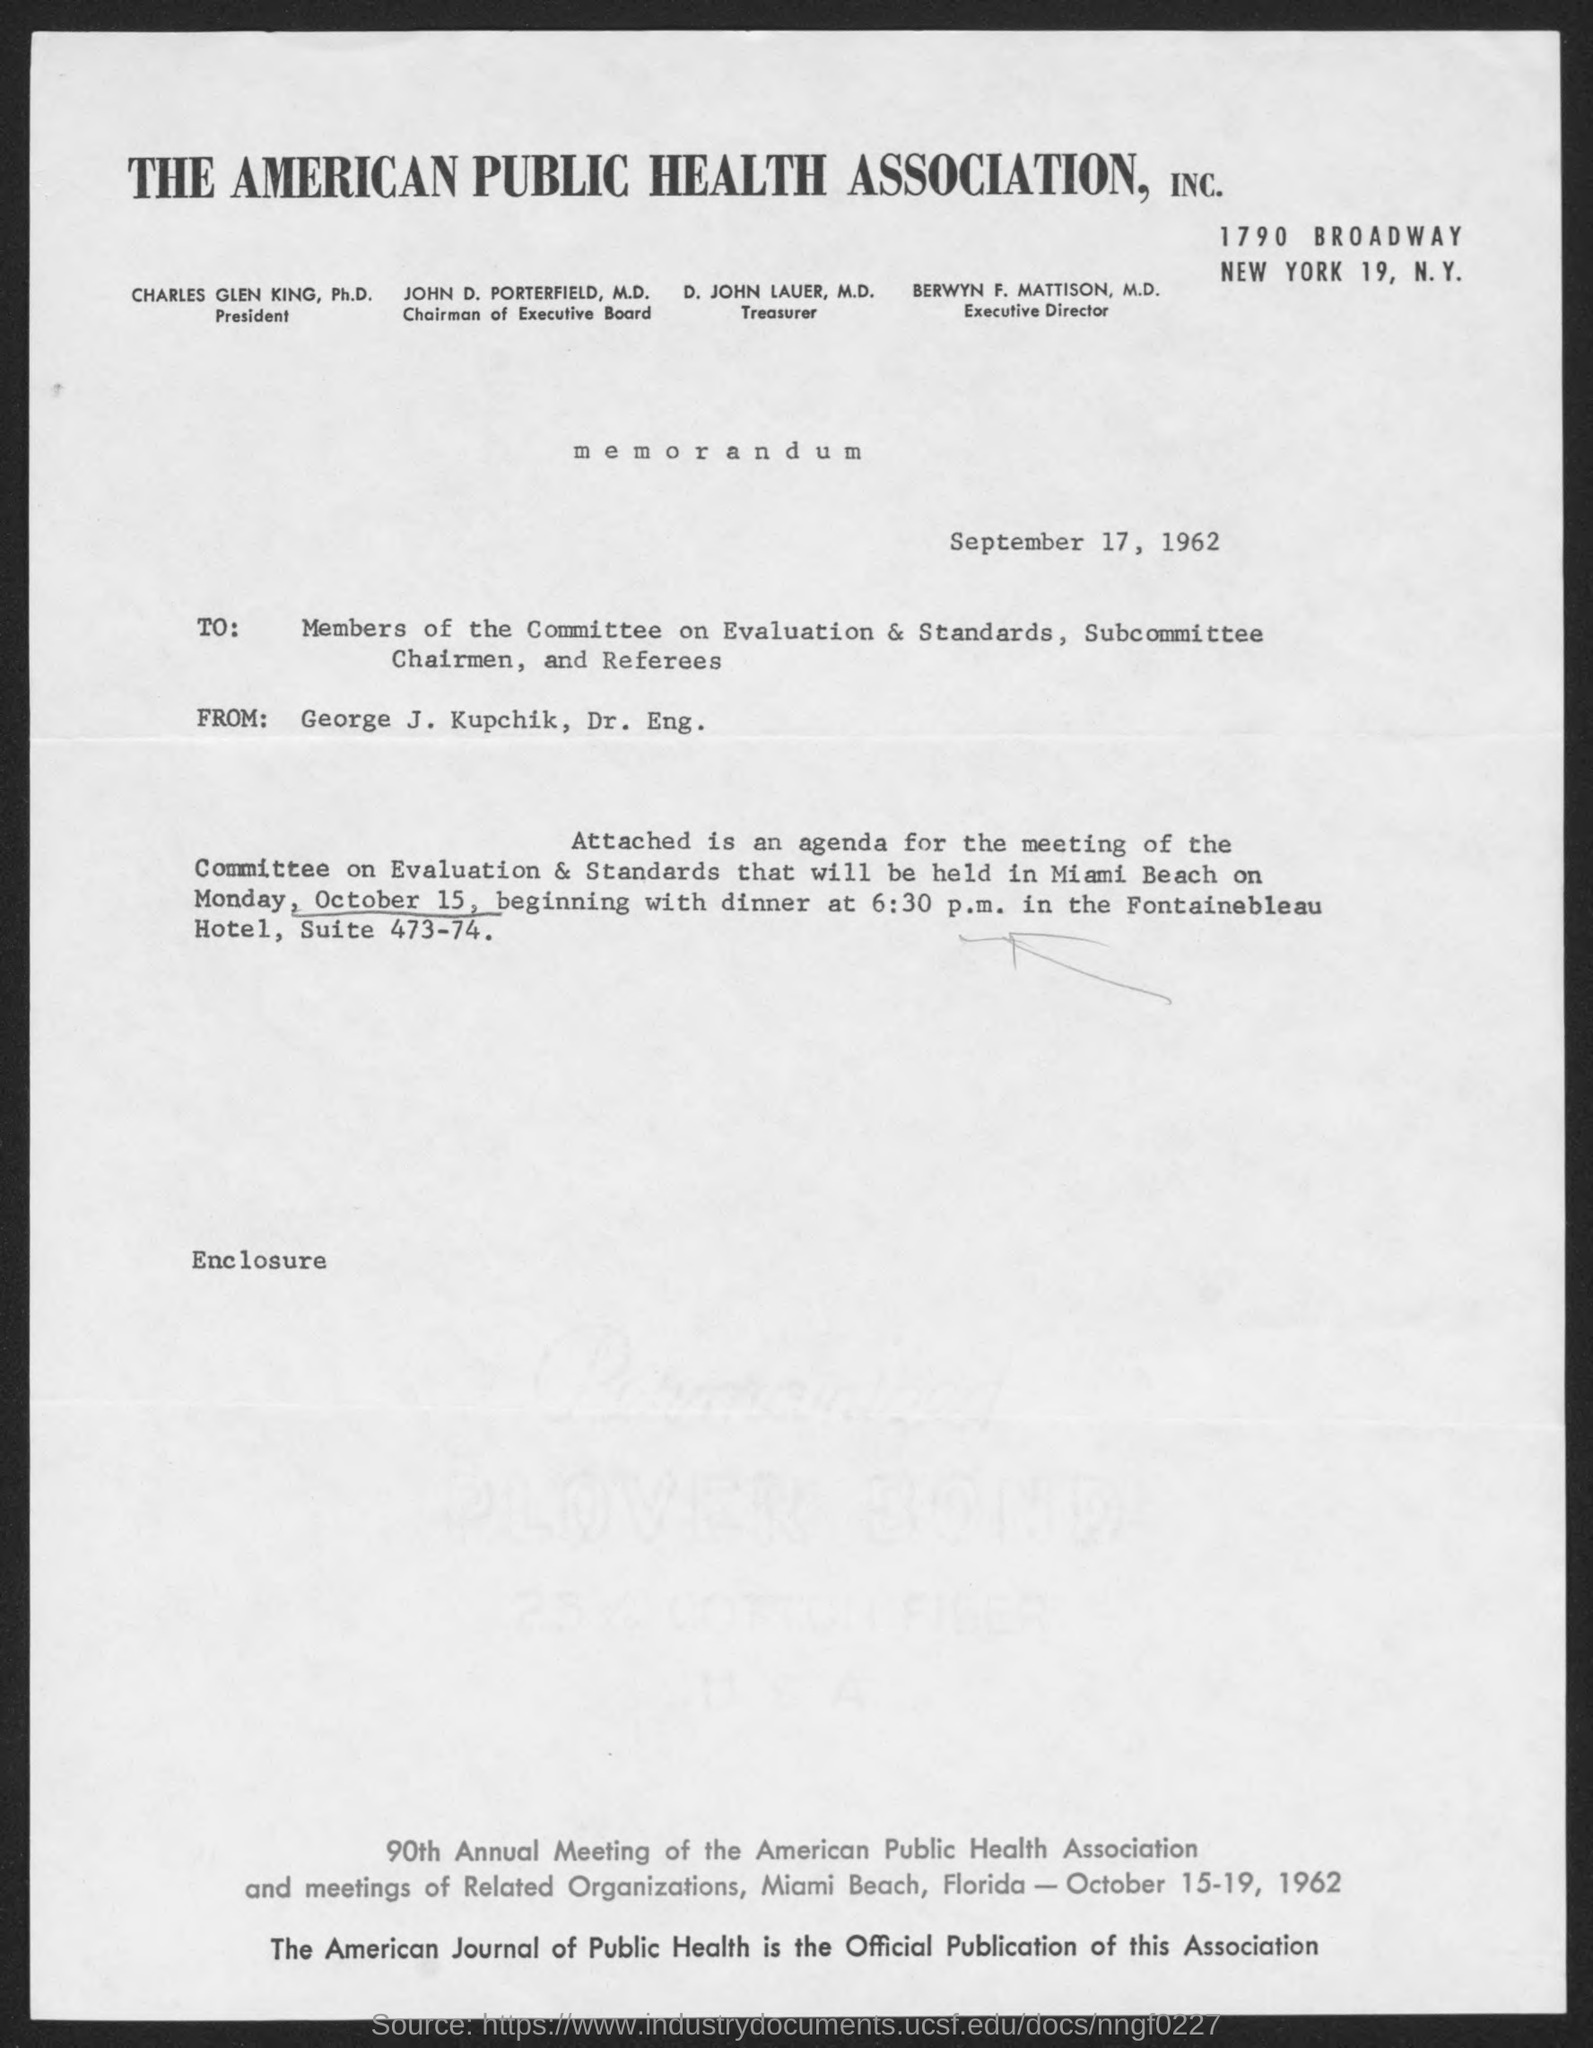What is the date?
Offer a very short reply. September 17, 1962. When the meeting of the committee on Evaluation & Standards will be held?
Keep it short and to the point. Monday, October 15. Who is the Treasurer of "The American Public Health Association" ?
Give a very brief answer. D. John Lauer, M.D. 